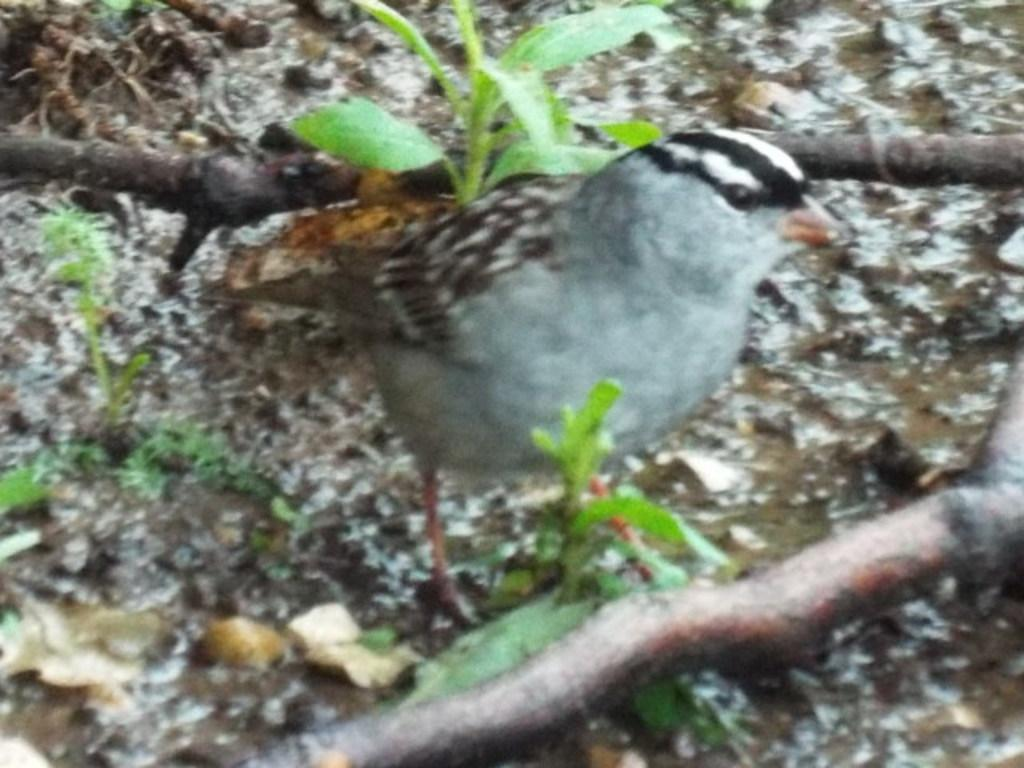What is the main subject in the center of the image? There is a bird in the center of the image. What type of vegetation can be seen in the image? There are plants in the image. What else is present in the image besides the bird and plants? There are twigs in the image. What type of flesh can be seen on the bird in the image? There is no flesh visible on the bird in the image; it is a bird and has feathers, not flesh. 